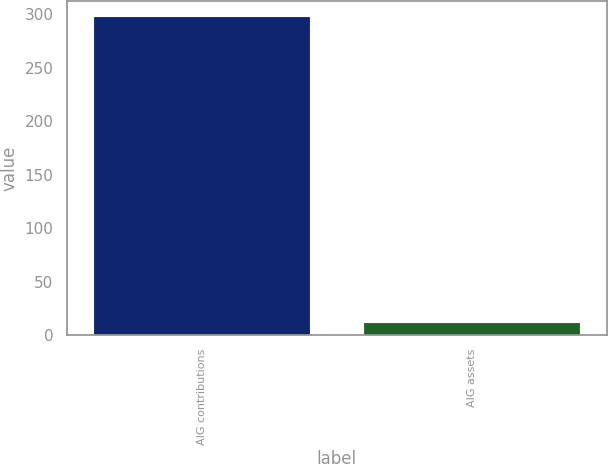Convert chart. <chart><loc_0><loc_0><loc_500><loc_500><bar_chart><fcel>AIG contributions<fcel>AIG assets<nl><fcel>298<fcel>11<nl></chart> 